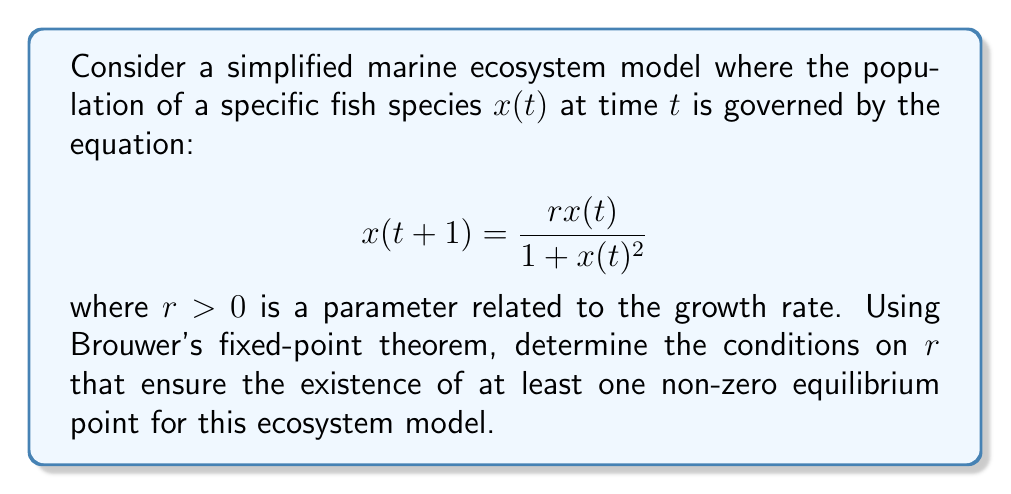Help me with this question. 1) First, let's recall Brouwer's fixed-point theorem: Any continuous function from a compact convex set to itself has a fixed point.

2) In our case, we're looking for fixed points of the function $f(x) = \frac{rx}{1 + x^2}$.

3) For a fixed point, we need $x = f(x)$, or:

   $$x = \frac{rx}{1 + x^2}$$

4) This is equivalent to solving:

   $$x(1 + x^2) = rx$$
   $$x^3 + x = rx$$
   $$x^3 - (r-1)x = 0$$
   $$x(x^2 - (r-1)) = 0$$

5) We're interested in non-zero solutions, so we need to solve:

   $$x^2 = r-1$$

6) For this to have real solutions, we need $r-1 \geq 0$, or $r \geq 1$.

7) Now, to apply Brouwer's theorem, we need to show that for $r \geq 1$, $f(x)$ maps some closed interval $[0,M]$ to itself.

8) Note that $f(0) = 0$ and $\lim_{x \to \infty} f(x) = 0$.

9) The maximum of $f(x)$ occurs at $x = 1$, where $f(1) = \frac{r}{2}$.

10) So, if we choose $M \geq \frac{r}{2}$, $f$ will map $[0,M]$ to itself.

11) Therefore, for $r \geq 1$, Brouwer's theorem guarantees the existence of a fixed point in $[0,M]$.

12) Since we've already shown that there are no fixed points in $(0,1)$ when $r > 1$, this fixed point must be the non-zero equilibrium we're looking for.
Answer: $r \geq 1$ 